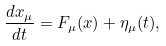Convert formula to latex. <formula><loc_0><loc_0><loc_500><loc_500>\frac { d x _ { \mu } } { d t } = F _ { \mu } ( x ) + \eta _ { \mu } ( t ) ,</formula> 